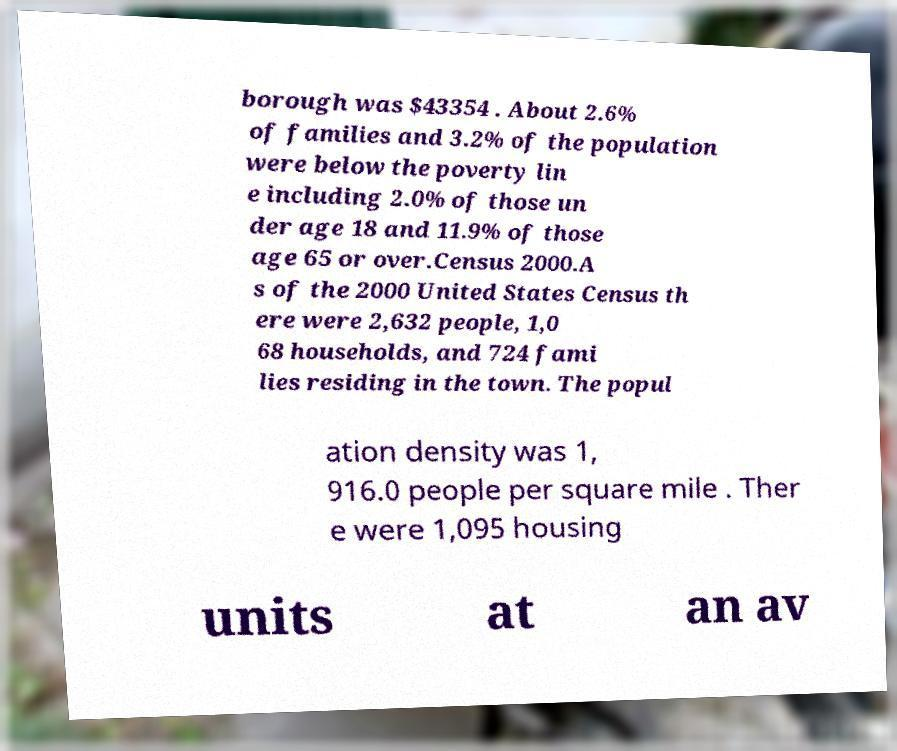Can you read and provide the text displayed in the image?This photo seems to have some interesting text. Can you extract and type it out for me? borough was $43354 . About 2.6% of families and 3.2% of the population were below the poverty lin e including 2.0% of those un der age 18 and 11.9% of those age 65 or over.Census 2000.A s of the 2000 United States Census th ere were 2,632 people, 1,0 68 households, and 724 fami lies residing in the town. The popul ation density was 1, 916.0 people per square mile . Ther e were 1,095 housing units at an av 